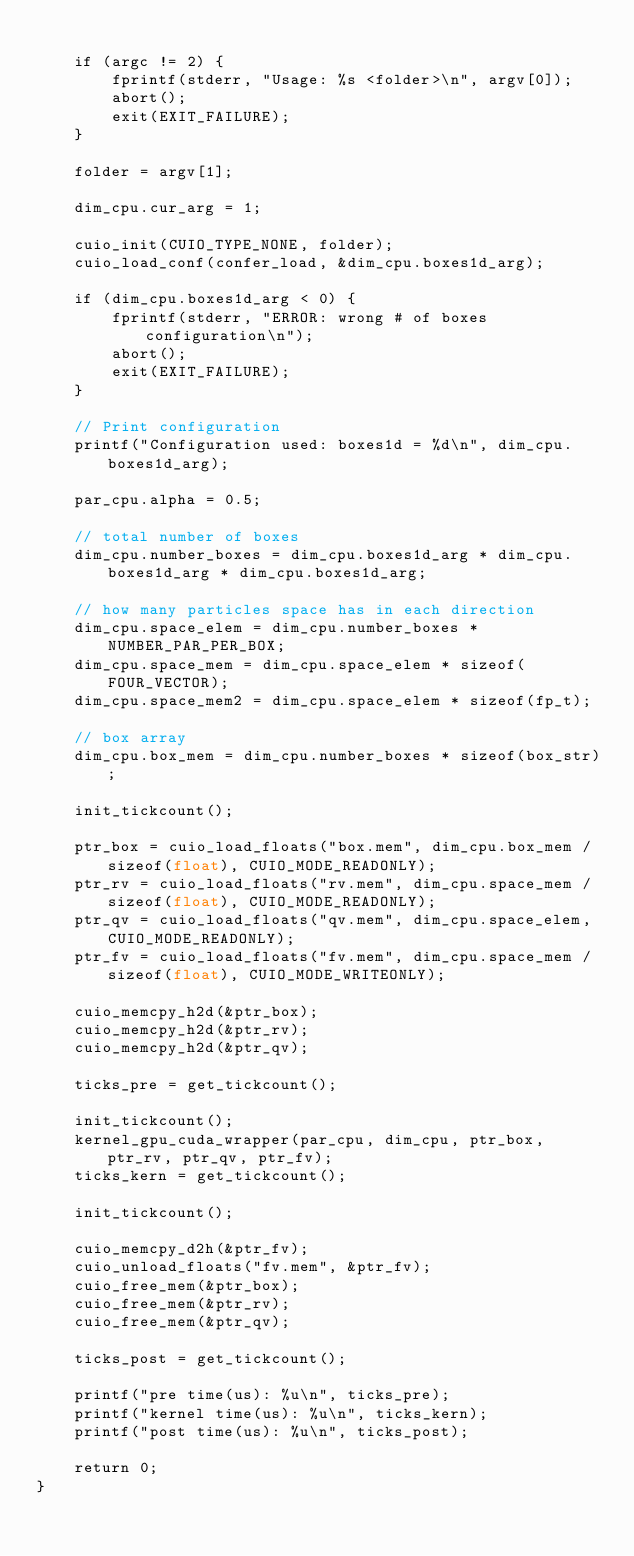<code> <loc_0><loc_0><loc_500><loc_500><_Cuda_>
	if (argc != 2) {
		fprintf(stderr, "Usage: %s <folder>\n", argv[0]);
		abort();
		exit(EXIT_FAILURE);
	}

	folder = argv[1];

	dim_cpu.cur_arg = 1;

	cuio_init(CUIO_TYPE_NONE, folder);
	cuio_load_conf(confer_load, &dim_cpu.boxes1d_arg);

	if (dim_cpu.boxes1d_arg < 0) {
		fprintf(stderr, "ERROR: wrong # of boxes configuration\n");
		abort();
		exit(EXIT_FAILURE);
	}

	// Print configuration
	printf("Configuration used: boxes1d = %d\n", dim_cpu.boxes1d_arg);

	par_cpu.alpha = 0.5;

	// total number of boxes
	dim_cpu.number_boxes = dim_cpu.boxes1d_arg * dim_cpu.boxes1d_arg * dim_cpu.boxes1d_arg;

	// how many particles space has in each direction
	dim_cpu.space_elem = dim_cpu.number_boxes * NUMBER_PAR_PER_BOX;
	dim_cpu.space_mem = dim_cpu.space_elem * sizeof(FOUR_VECTOR);
	dim_cpu.space_mem2 = dim_cpu.space_elem * sizeof(fp_t);

	// box array
	dim_cpu.box_mem = dim_cpu.number_boxes * sizeof(box_str);

	init_tickcount();

	ptr_box = cuio_load_floats("box.mem", dim_cpu.box_mem / sizeof(float), CUIO_MODE_READONLY);
	ptr_rv = cuio_load_floats("rv.mem", dim_cpu.space_mem / sizeof(float), CUIO_MODE_READONLY);
	ptr_qv = cuio_load_floats("qv.mem", dim_cpu.space_elem, CUIO_MODE_READONLY);
	ptr_fv = cuio_load_floats("fv.mem", dim_cpu.space_mem / sizeof(float), CUIO_MODE_WRITEONLY);

	cuio_memcpy_h2d(&ptr_box);
	cuio_memcpy_h2d(&ptr_rv);
	cuio_memcpy_h2d(&ptr_qv);

	ticks_pre = get_tickcount();
	
	init_tickcount();
	kernel_gpu_cuda_wrapper(par_cpu, dim_cpu, ptr_box, ptr_rv, ptr_qv, ptr_fv);
	ticks_kern = get_tickcount();

	init_tickcount();

	cuio_memcpy_d2h(&ptr_fv);
	cuio_unload_floats("fv.mem", &ptr_fv);
	cuio_free_mem(&ptr_box);
	cuio_free_mem(&ptr_rv);
	cuio_free_mem(&ptr_qv);

	ticks_post = get_tickcount();

	printf("pre time(us): %u\n", ticks_pre);
	printf("kernel time(us): %u\n", ticks_kern);
	printf("post time(us): %u\n", ticks_post);

	return 0;
}
</code> 